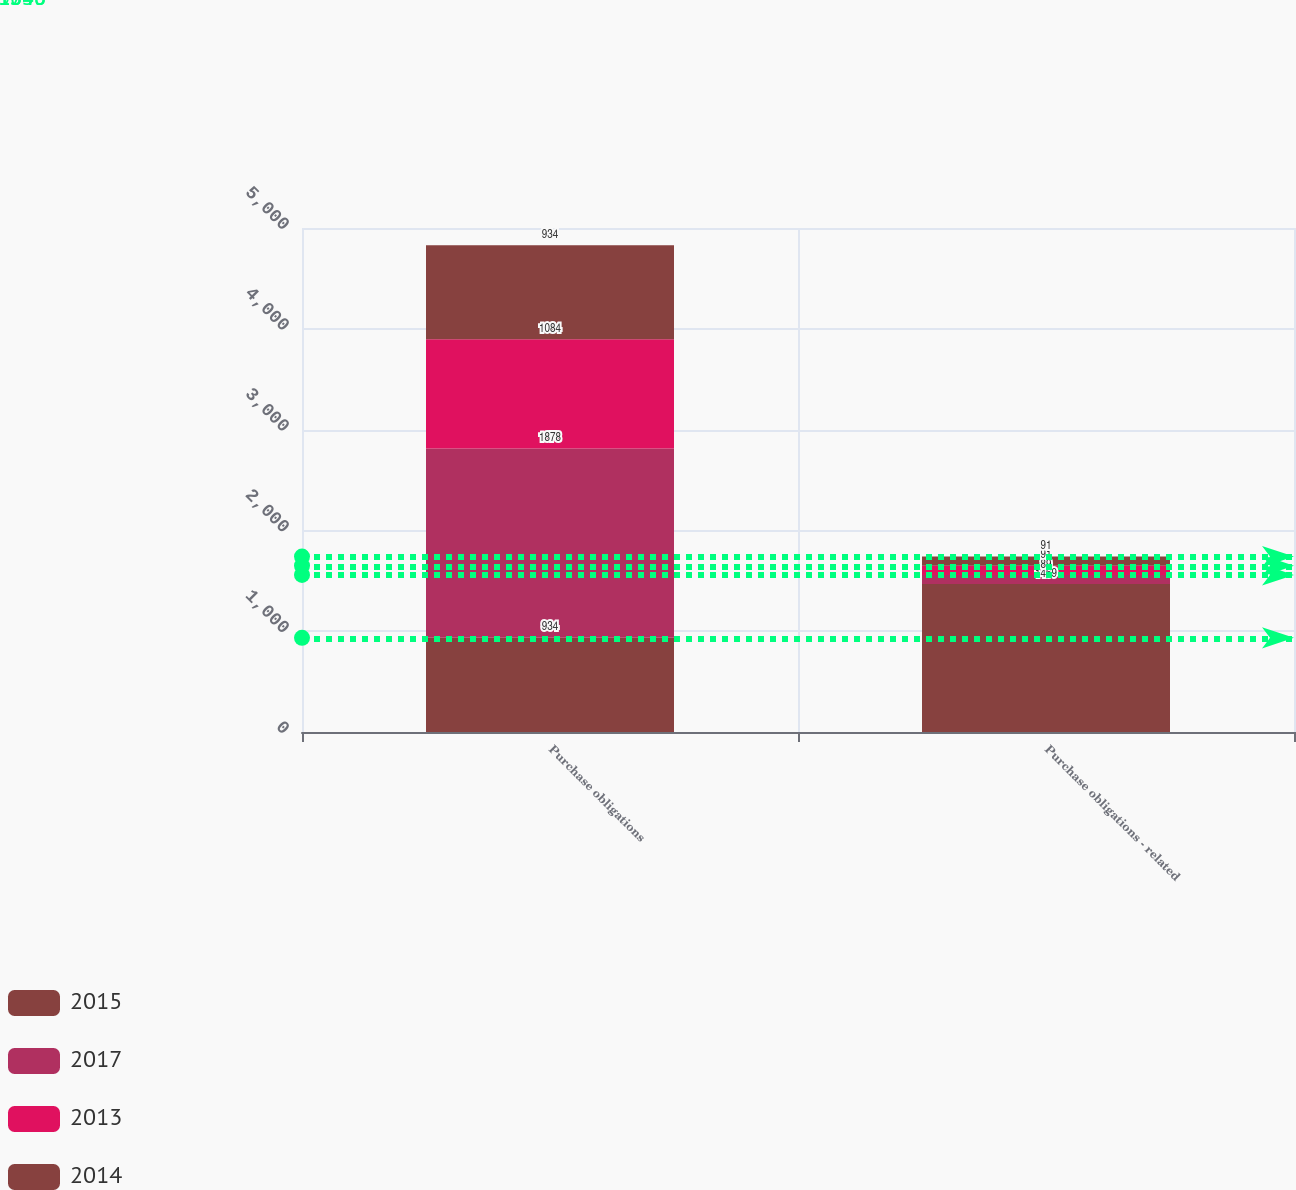<chart> <loc_0><loc_0><loc_500><loc_500><stacked_bar_chart><ecel><fcel>Purchase obligations<fcel>Purchase obligations - related<nl><fcel>2015<fcel>934<fcel>1469<nl><fcel>2017<fcel>1878<fcel>89<nl><fcel>2013<fcel>1084<fcel>91<nl><fcel>2014<fcel>934<fcel>91<nl></chart> 